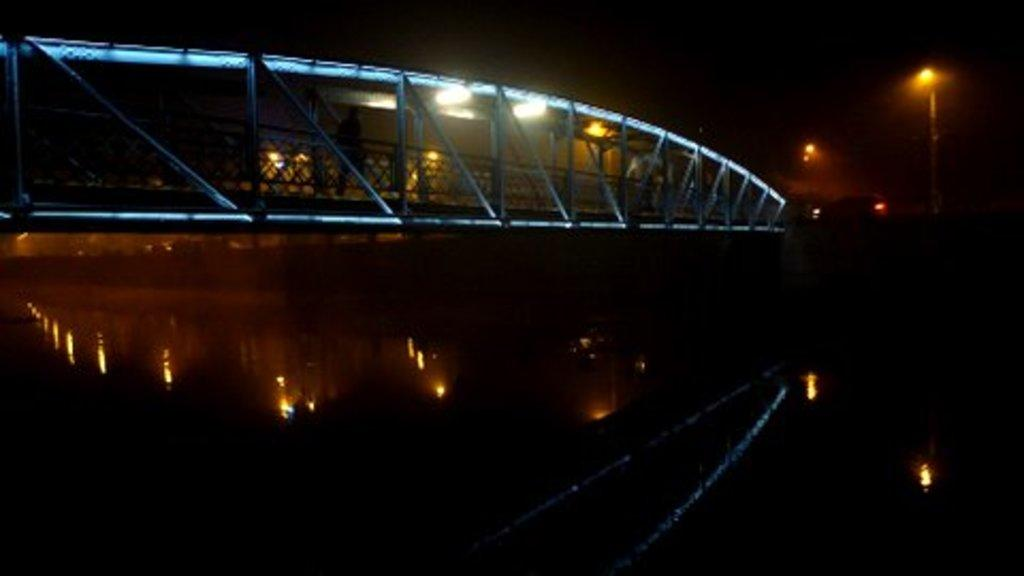What type of structure is depicted in the image? The image shows a suspension bridge. What natural feature can be seen behind the bridge? There is a river visible behind the bridge. Can you describe any additional structures or objects in the image? There is a light pole on the right side of the image. How would you describe the overall lighting in the image? The background of the image is dark. What type of print can be seen on the bell in the image? There is no bell present in the image; it features a suspension bridge and a river. How many baskets are hanging from the bridge in the image? There are no baskets hanging from the bridge in the image; it only shows a suspension bridge and a river. 